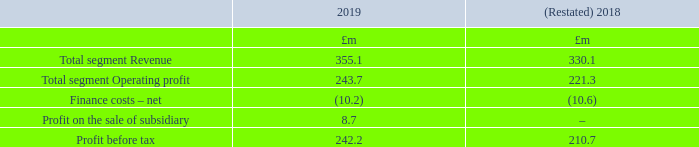4. Segmental information
IFRS 8 ‘Operating segments’ requires the Group to determine its operating segments based on information which is provided internally. Based on the internal reporting information and management structures within the Group, it has been determined that there is only one operating segment, being the Group, as the information reported includes operating results at a consolidated Group level only. This reflects the nature of the business, where the major cost is to support the IT platforms upon which all of the Group’s customers are serviced. These costs are borne centrally and are not attributable to any specific customer type or revenue stream. There is also considered to be only one reporting segment, which is the Group, the results of which are shown in the Consolidated income statement.
Management has determined that there is one operating and reporting segment based on the reports reviewed by the Operational Leadership Team (‘OLT’) which is the chief operating decision-maker (‘CODM’). The OLT is made up of the Executive Directors and Key Management and is responsible for the strategic decision-making of the Group.
The OLT primarily uses the statutory measures of Revenue and Operating profit to assess the performance of the one operating segment. To assist in the analysis of the Group’s revenue-generating trends, the OLT reviews revenue at a disaggregated level as detailed within note 5. The revenue from external parties reported to the OLT is measured in a manner consistent with that in the income statement.
A reconciliation of the one segment’s Operating profit to Profit before tax is shown below.
Following the application of IFRS 16, profit before tax for the year ended 31 March 2018 has been restated (note 2).
What is the Operational Leadership Team made up of? Made up of the executive directors and key management and is responsible for the strategic decision-making of the group. What led to the restating of the 2018 values for profit before tax in the table? The application of ifrs 16. What are the components in the table which are considered when reconciliating total segment revenue to profit before tax? Total segment operating profit, finance costs – net, profit on the sale of subsidiary. In which year was Total segment Operating profit larger? 243.7>221.3
Answer: 2019. What was the change in Total segment Operating profit in 2019 from 2018?
Answer scale should be: million. 243.7-221.3
Answer: 22.4. What was the percentage change in Total segment Operating profit in 2019 from 2018?
Answer scale should be: percent. (243.7-221.3)/221.3
Answer: 10.12. 